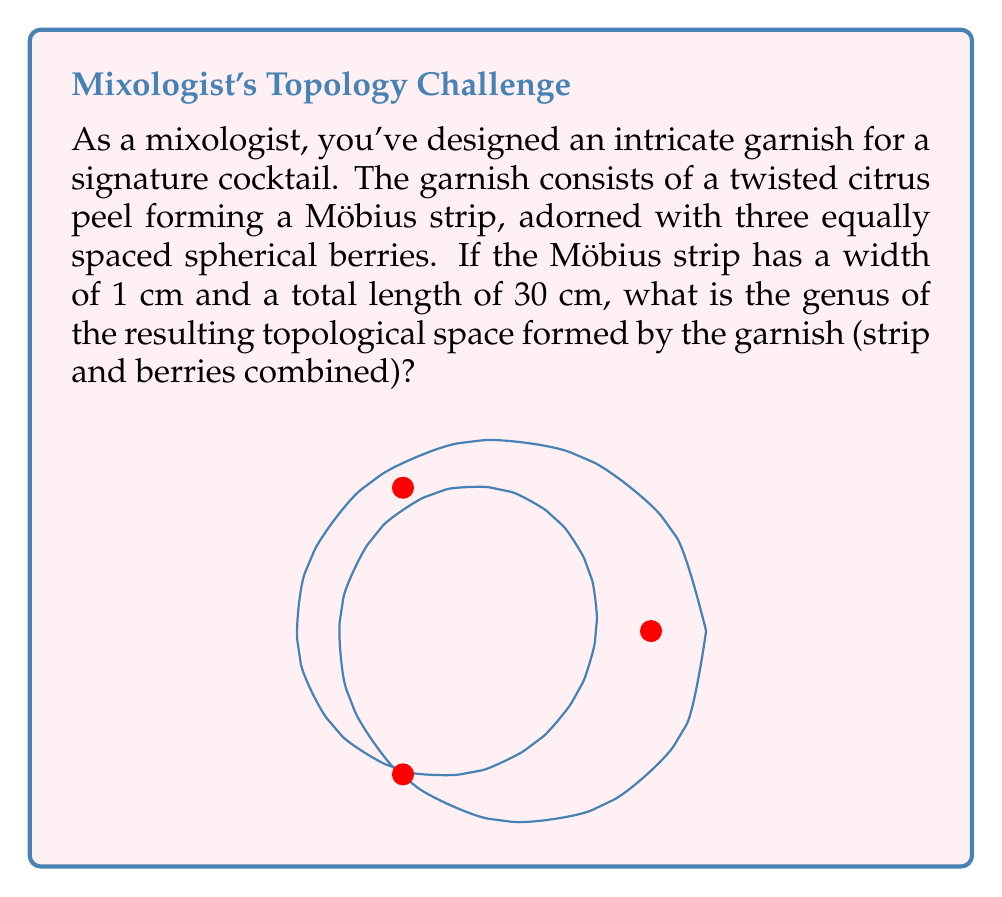Show me your answer to this math problem. To solve this problem, let's break it down into steps:

1) First, we need to understand the topological properties of the components:
   - A Möbius strip has a genus of 0 and is non-orientable.
   - Each berry (sphere) has a genus of 0.

2) When we combine these objects, we need to consider how they interact topologically:
   - The Möbius strip forms the base of our space.
   - Each berry is attached to the strip at a single point.

3) In topology, when we attach a sphere to a surface at a single point, it doesn't change the genus of the surface. This is because a sphere can be continuously deformed into a point without changing the topological properties of the space.

4) Therefore, despite adding three berries, the genus of the entire space remains the same as that of the Möbius strip alone.

5) The genus of a Möbius strip is 0.

Thus, the genus of the entire garnish (Möbius strip with three berries) is 0.

It's worth noting that while the genus hasn't changed, the Euler characteristic of the space has been affected. Each berry increases the Euler characteristic by 1, but this doesn't impact the genus in this case.
Answer: 0 